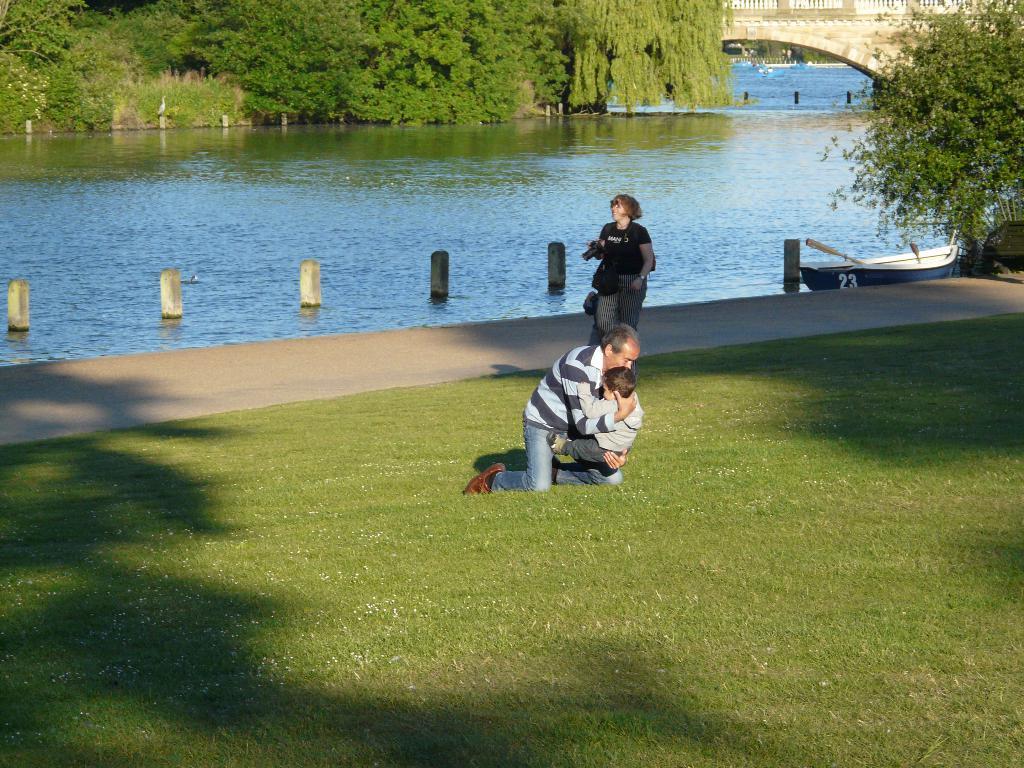Describe this image in one or two sentences. In this image we can see a man holding the boy. We can also see a woman walking on the grass. There is also a path, boat on the surface of the water. We can also see some roads, trees and also the bridge. 